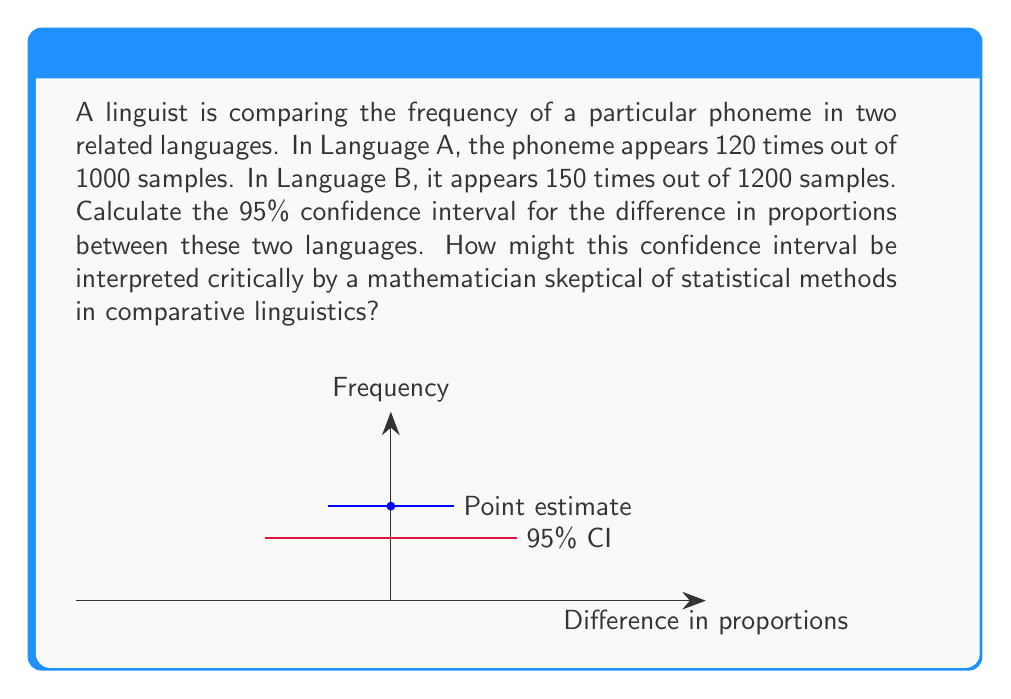Show me your answer to this math problem. Let's approach this step-by-step:

1) First, we calculate the proportions:
   Language A: $p_A = \frac{120}{1000} = 0.12$
   Language B: $p_B = \frac{150}{1200} = 0.125$

2) The difference in proportions is:
   $\hat{p} = p_B - p_A = 0.125 - 0.12 = 0.005$

3) To calculate the confidence interval, we need the standard error of the difference:
   $SE = \sqrt{\frac{p_A(1-p_A)}{n_A} + \frac{p_B(1-p_B)}{n_B}}$
   $SE = \sqrt{\frac{0.12(0.88)}{1000} + \frac{0.125(0.875)}{1200}} \approx 0.0139$

4) For a 95% confidence interval, we use a z-score of 1.96:
   $CI = \hat{p} \pm 1.96 * SE$
   $CI = 0.005 \pm 1.96 * 0.0139$
   $CI = 0.005 \pm 0.0272$
   $CI = [-0.0222, 0.0322]$

5) Interpretation: We can be 95% confident that the true difference in proportions lies between -0.0222 and 0.0322.

However, a skeptical mathematician might question:
- The assumption of normality for proportions
- The arbitrary nature of the 95% confidence level
- The interpretation of "confidence" itself
- The potential for Type I errors in multiple comparisons across languages
- The linguistic relevance of statistical significance in phoneme frequency
Answer: 95% CI: [-0.0222, 0.0322]; skepticism warranted on normality assumptions, confidence level arbitrariness, and linguistic relevance. 